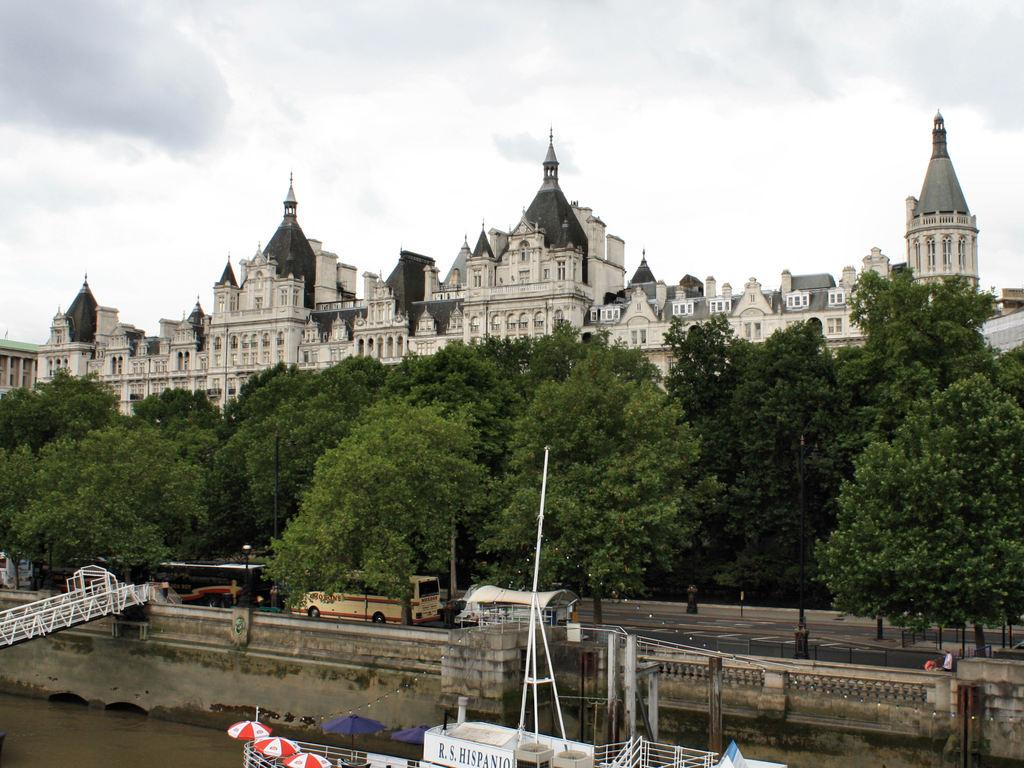What type of vegetation is present at the bottom of the image? There are trees at the bottom of the image. What is happening on the road in the image? Vehicles are moving on the road in the image. What type of structures can be seen in the middle of the image? There are big buildings in the middle of the image. What is visible at the top of the image? The sky is visible at the top of the image. How many bikes are circling around the trees at the bottom of the image? There are no bikes present in the image, and they are not circling around the trees. 